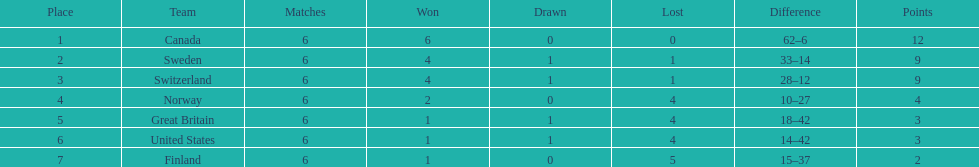Which country's team came in last place during the 1951 world ice hockey championships? Finland. 